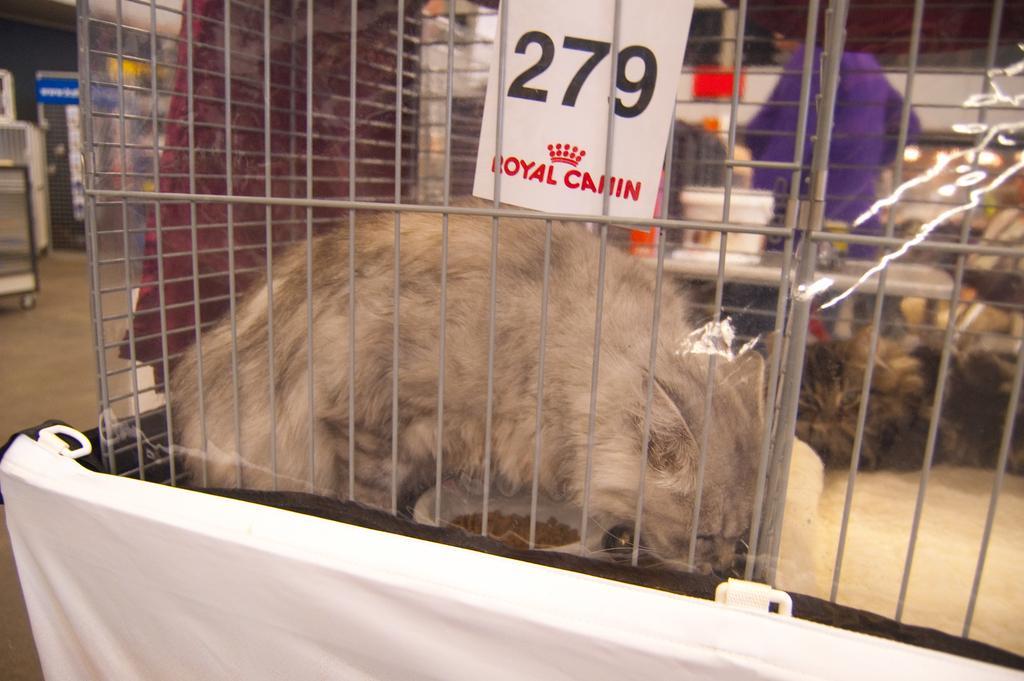In one or two sentences, can you explain what this image depicts? In this image there are few animals in the cage having a tag to it. On the tag there is some text. Behind the cage there is a table having few objects on it. Behind the table there is a person standing. Left side there is a trolley on the floor. Behind there are few objects. 